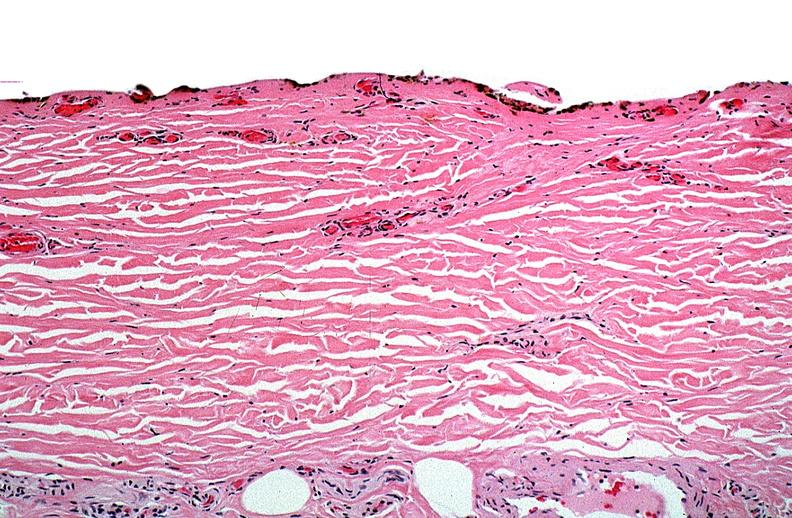does intramural one lesion show thermal burned skin?
Answer the question using a single word or phrase. No 